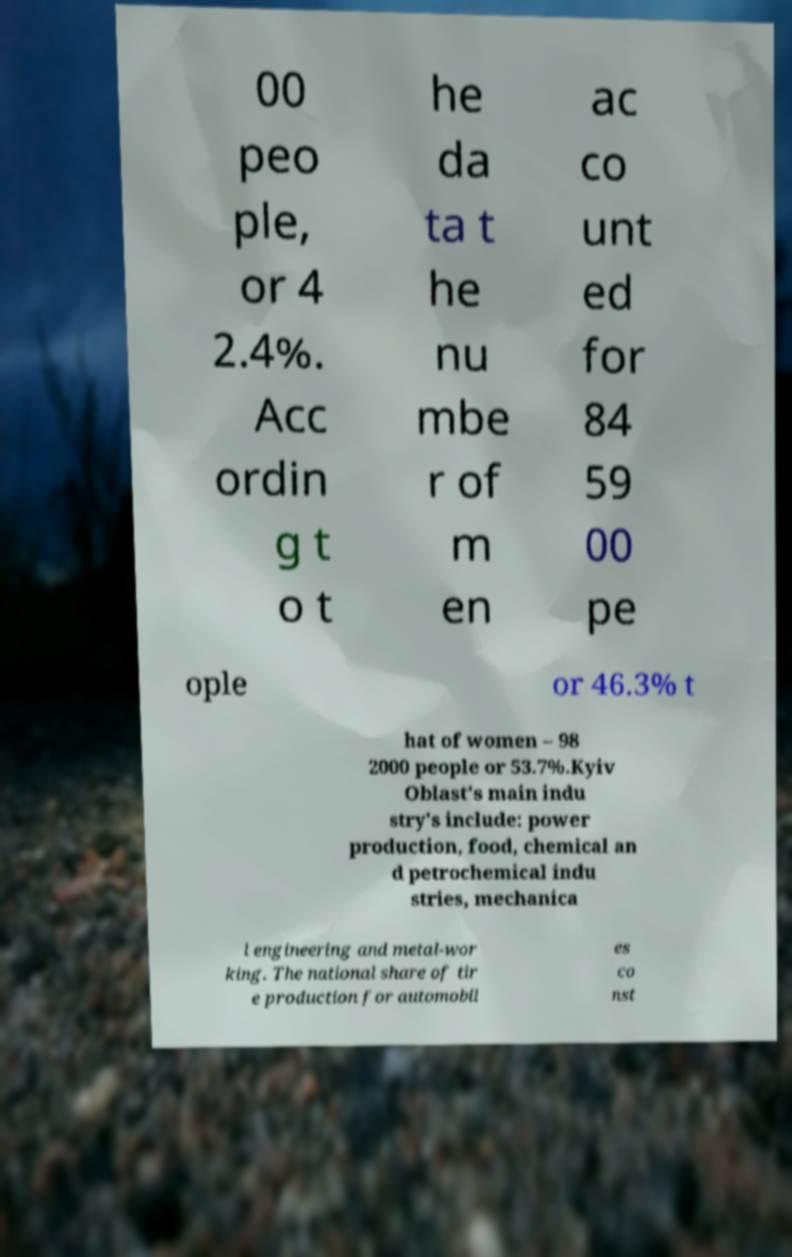Can you read and provide the text displayed in the image?This photo seems to have some interesting text. Can you extract and type it out for me? 00 peo ple, or 4 2.4%. Acc ordin g t o t he da ta t he nu mbe r of m en ac co unt ed for 84 59 00 pe ople or 46.3% t hat of women – 98 2000 people or 53.7%.Kyiv Oblast's main indu stry's include: power production, food, chemical an d petrochemical indu stries, mechanica l engineering and metal-wor king. The national share of tir e production for automobil es co nst 